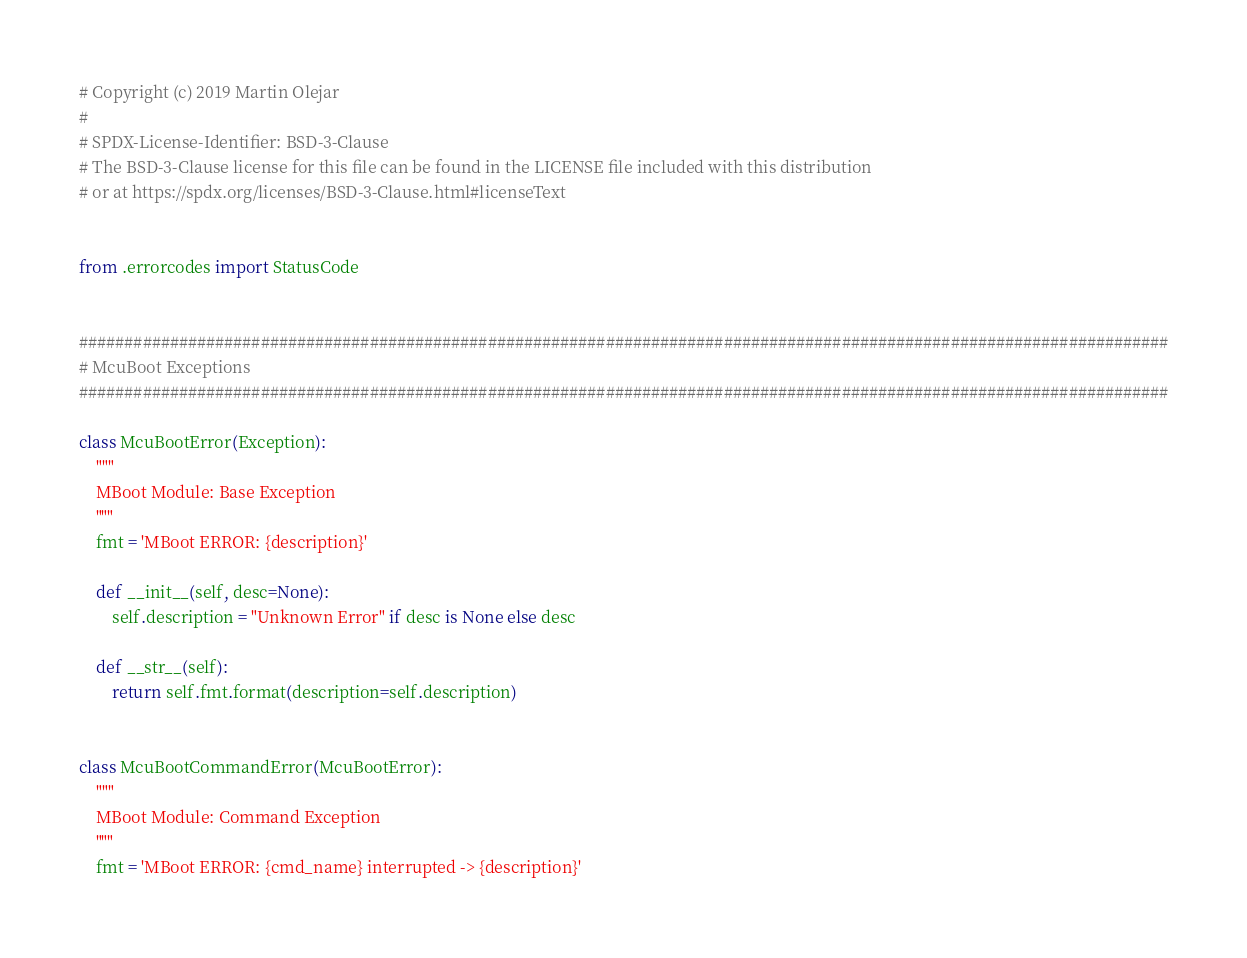<code> <loc_0><loc_0><loc_500><loc_500><_Python_># Copyright (c) 2019 Martin Olejar
#
# SPDX-License-Identifier: BSD-3-Clause
# The BSD-3-Clause license for this file can be found in the LICENSE file included with this distribution
# or at https://spdx.org/licenses/BSD-3-Clause.html#licenseText


from .errorcodes import StatusCode


########################################################################################################################
# McuBoot Exceptions
########################################################################################################################

class McuBootError(Exception):
    """
    MBoot Module: Base Exception
    """
    fmt = 'MBoot ERROR: {description}'

    def __init__(self, desc=None):
        self.description = "Unknown Error" if desc is None else desc

    def __str__(self):
        return self.fmt.format(description=self.description)


class McuBootCommandError(McuBootError):
    """
    MBoot Module: Command Exception
    """
    fmt = 'MBoot ERROR: {cmd_name} interrupted -> {description}'
</code> 